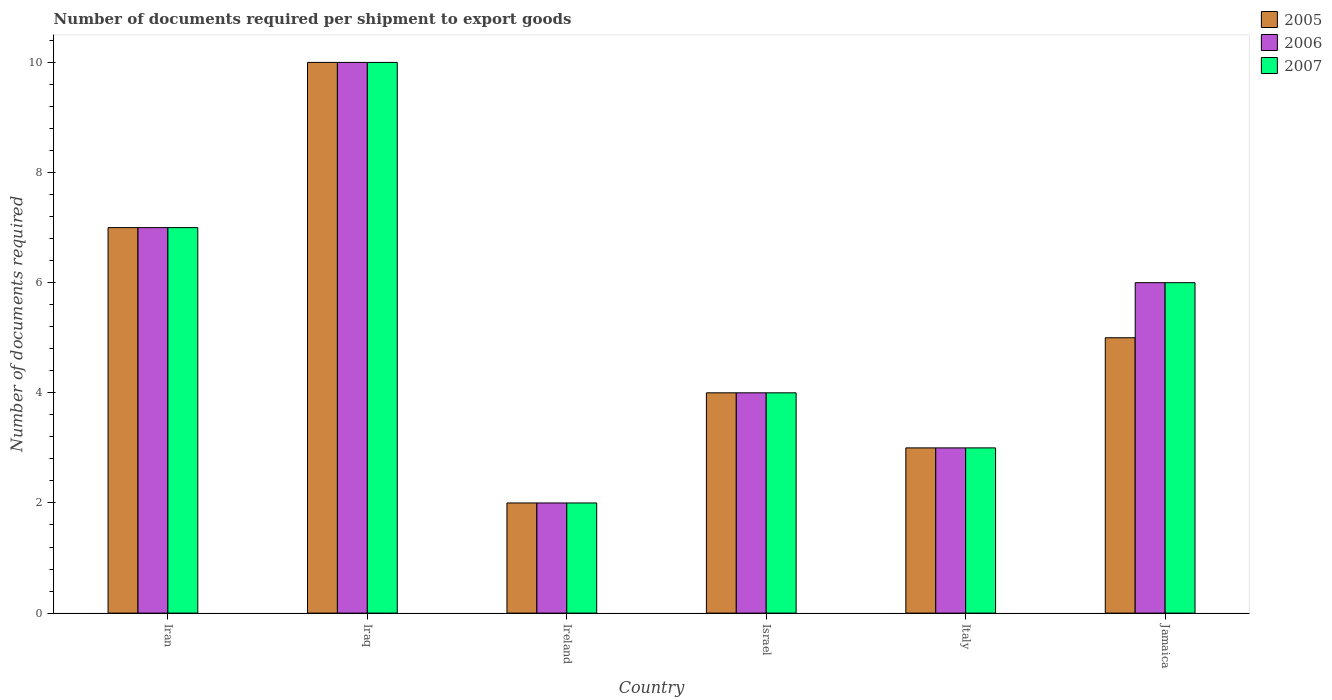What is the label of the 1st group of bars from the left?
Your answer should be compact. Iran. What is the number of documents required per shipment to export goods in 2006 in Jamaica?
Provide a succinct answer. 6. In which country was the number of documents required per shipment to export goods in 2007 maximum?
Your answer should be compact. Iraq. In which country was the number of documents required per shipment to export goods in 2007 minimum?
Keep it short and to the point. Ireland. What is the total number of documents required per shipment to export goods in 2006 in the graph?
Your answer should be very brief. 32. What is the difference between the number of documents required per shipment to export goods in 2005 in Ireland and the number of documents required per shipment to export goods in 2006 in Italy?
Your answer should be very brief. -1. What is the average number of documents required per shipment to export goods in 2005 per country?
Your answer should be very brief. 5.17. What is the ratio of the number of documents required per shipment to export goods in 2007 in Ireland to that in Jamaica?
Ensure brevity in your answer.  0.33. Is the number of documents required per shipment to export goods in 2005 in Israel less than that in Italy?
Provide a succinct answer. No. Is the difference between the number of documents required per shipment to export goods in 2007 in Italy and Jamaica greater than the difference between the number of documents required per shipment to export goods in 2006 in Italy and Jamaica?
Your answer should be very brief. No. In how many countries, is the number of documents required per shipment to export goods in 2005 greater than the average number of documents required per shipment to export goods in 2005 taken over all countries?
Ensure brevity in your answer.  2. What does the 1st bar from the right in Italy represents?
Your answer should be compact. 2007. Are all the bars in the graph horizontal?
Your response must be concise. No. What is the difference between two consecutive major ticks on the Y-axis?
Ensure brevity in your answer.  2. Does the graph contain any zero values?
Your answer should be compact. No. Where does the legend appear in the graph?
Offer a terse response. Top right. How many legend labels are there?
Offer a terse response. 3. How are the legend labels stacked?
Give a very brief answer. Vertical. What is the title of the graph?
Make the answer very short. Number of documents required per shipment to export goods. Does "1972" appear as one of the legend labels in the graph?
Offer a terse response. No. What is the label or title of the Y-axis?
Your answer should be very brief. Number of documents required. What is the Number of documents required in 2005 in Iran?
Offer a very short reply. 7. What is the Number of documents required of 2007 in Iran?
Give a very brief answer. 7. What is the Number of documents required of 2006 in Iraq?
Offer a terse response. 10. What is the Number of documents required in 2005 in Ireland?
Your answer should be very brief. 2. What is the Number of documents required of 2006 in Ireland?
Offer a very short reply. 2. What is the Number of documents required in 2005 in Italy?
Provide a succinct answer. 3. What is the Number of documents required in 2006 in Italy?
Offer a terse response. 3. Across all countries, what is the maximum Number of documents required in 2005?
Your answer should be very brief. 10. Across all countries, what is the maximum Number of documents required in 2007?
Offer a terse response. 10. Across all countries, what is the minimum Number of documents required in 2005?
Provide a succinct answer. 2. Across all countries, what is the minimum Number of documents required in 2006?
Offer a very short reply. 2. Across all countries, what is the minimum Number of documents required of 2007?
Keep it short and to the point. 2. What is the total Number of documents required in 2005 in the graph?
Your answer should be compact. 31. What is the total Number of documents required of 2007 in the graph?
Give a very brief answer. 32. What is the difference between the Number of documents required in 2006 in Iran and that in Iraq?
Provide a succinct answer. -3. What is the difference between the Number of documents required in 2007 in Iran and that in Iraq?
Give a very brief answer. -3. What is the difference between the Number of documents required in 2005 in Iran and that in Ireland?
Your response must be concise. 5. What is the difference between the Number of documents required in 2006 in Iran and that in Israel?
Provide a short and direct response. 3. What is the difference between the Number of documents required in 2005 in Iran and that in Italy?
Offer a very short reply. 4. What is the difference between the Number of documents required in 2006 in Iran and that in Italy?
Make the answer very short. 4. What is the difference between the Number of documents required in 2005 in Iran and that in Jamaica?
Provide a succinct answer. 2. What is the difference between the Number of documents required of 2007 in Iran and that in Jamaica?
Offer a terse response. 1. What is the difference between the Number of documents required in 2005 in Iraq and that in Israel?
Give a very brief answer. 6. What is the difference between the Number of documents required in 2006 in Iraq and that in Italy?
Your response must be concise. 7. What is the difference between the Number of documents required in 2006 in Ireland and that in Israel?
Offer a terse response. -2. What is the difference between the Number of documents required in 2007 in Ireland and that in Israel?
Your response must be concise. -2. What is the difference between the Number of documents required of 2005 in Israel and that in Italy?
Your response must be concise. 1. What is the difference between the Number of documents required of 2007 in Israel and that in Italy?
Provide a short and direct response. 1. What is the difference between the Number of documents required in 2007 in Israel and that in Jamaica?
Make the answer very short. -2. What is the difference between the Number of documents required of 2005 in Italy and that in Jamaica?
Ensure brevity in your answer.  -2. What is the difference between the Number of documents required of 2006 in Italy and that in Jamaica?
Your response must be concise. -3. What is the difference between the Number of documents required of 2007 in Italy and that in Jamaica?
Make the answer very short. -3. What is the difference between the Number of documents required of 2006 in Iran and the Number of documents required of 2007 in Iraq?
Provide a succinct answer. -3. What is the difference between the Number of documents required of 2005 in Iran and the Number of documents required of 2006 in Ireland?
Give a very brief answer. 5. What is the difference between the Number of documents required in 2006 in Iran and the Number of documents required in 2007 in Ireland?
Make the answer very short. 5. What is the difference between the Number of documents required in 2005 in Iran and the Number of documents required in 2007 in Israel?
Ensure brevity in your answer.  3. What is the difference between the Number of documents required in 2006 in Iran and the Number of documents required in 2007 in Israel?
Make the answer very short. 3. What is the difference between the Number of documents required of 2005 in Iran and the Number of documents required of 2007 in Italy?
Offer a terse response. 4. What is the difference between the Number of documents required of 2005 in Iraq and the Number of documents required of 2007 in Ireland?
Provide a succinct answer. 8. What is the difference between the Number of documents required in 2005 in Iraq and the Number of documents required in 2007 in Italy?
Your answer should be compact. 7. What is the difference between the Number of documents required in 2006 in Iraq and the Number of documents required in 2007 in Italy?
Your answer should be compact. 7. What is the difference between the Number of documents required in 2005 in Iraq and the Number of documents required in 2006 in Jamaica?
Offer a very short reply. 4. What is the difference between the Number of documents required in 2005 in Iraq and the Number of documents required in 2007 in Jamaica?
Give a very brief answer. 4. What is the difference between the Number of documents required of 2006 in Ireland and the Number of documents required of 2007 in Israel?
Offer a very short reply. -2. What is the difference between the Number of documents required of 2005 in Ireland and the Number of documents required of 2007 in Italy?
Ensure brevity in your answer.  -1. What is the difference between the Number of documents required of 2006 in Ireland and the Number of documents required of 2007 in Italy?
Your response must be concise. -1. What is the difference between the Number of documents required in 2005 in Ireland and the Number of documents required in 2006 in Jamaica?
Keep it short and to the point. -4. What is the difference between the Number of documents required in 2005 in Ireland and the Number of documents required in 2007 in Jamaica?
Offer a very short reply. -4. What is the difference between the Number of documents required of 2006 in Ireland and the Number of documents required of 2007 in Jamaica?
Provide a succinct answer. -4. What is the difference between the Number of documents required in 2005 in Israel and the Number of documents required in 2006 in Italy?
Make the answer very short. 1. What is the difference between the Number of documents required of 2005 in Israel and the Number of documents required of 2007 in Jamaica?
Provide a succinct answer. -2. What is the difference between the Number of documents required of 2006 in Israel and the Number of documents required of 2007 in Jamaica?
Offer a very short reply. -2. What is the difference between the Number of documents required in 2005 in Italy and the Number of documents required in 2007 in Jamaica?
Provide a short and direct response. -3. What is the average Number of documents required of 2005 per country?
Your response must be concise. 5.17. What is the average Number of documents required of 2006 per country?
Offer a terse response. 5.33. What is the average Number of documents required in 2007 per country?
Keep it short and to the point. 5.33. What is the difference between the Number of documents required of 2006 and Number of documents required of 2007 in Iran?
Make the answer very short. 0. What is the difference between the Number of documents required in 2005 and Number of documents required in 2007 in Iraq?
Ensure brevity in your answer.  0. What is the difference between the Number of documents required of 2005 and Number of documents required of 2006 in Ireland?
Your answer should be compact. 0. What is the difference between the Number of documents required in 2005 and Number of documents required in 2007 in Ireland?
Your answer should be compact. 0. What is the difference between the Number of documents required in 2006 and Number of documents required in 2007 in Ireland?
Make the answer very short. 0. What is the difference between the Number of documents required in 2005 and Number of documents required in 2006 in Israel?
Your response must be concise. 0. What is the difference between the Number of documents required of 2005 and Number of documents required of 2007 in Israel?
Provide a succinct answer. 0. What is the difference between the Number of documents required in 2006 and Number of documents required in 2007 in Israel?
Your response must be concise. 0. What is the difference between the Number of documents required of 2005 and Number of documents required of 2007 in Italy?
Provide a succinct answer. 0. What is the difference between the Number of documents required in 2005 and Number of documents required in 2006 in Jamaica?
Offer a very short reply. -1. What is the ratio of the Number of documents required in 2005 in Iran to that in Ireland?
Your response must be concise. 3.5. What is the ratio of the Number of documents required of 2006 in Iran to that in Ireland?
Ensure brevity in your answer.  3.5. What is the ratio of the Number of documents required in 2007 in Iran to that in Ireland?
Offer a very short reply. 3.5. What is the ratio of the Number of documents required of 2005 in Iran to that in Italy?
Provide a short and direct response. 2.33. What is the ratio of the Number of documents required in 2006 in Iran to that in Italy?
Your answer should be compact. 2.33. What is the ratio of the Number of documents required of 2007 in Iran to that in Italy?
Offer a very short reply. 2.33. What is the ratio of the Number of documents required of 2005 in Iran to that in Jamaica?
Ensure brevity in your answer.  1.4. What is the ratio of the Number of documents required of 2007 in Iran to that in Jamaica?
Offer a terse response. 1.17. What is the ratio of the Number of documents required of 2005 in Iraq to that in Israel?
Your answer should be very brief. 2.5. What is the ratio of the Number of documents required of 2006 in Iraq to that in Italy?
Your answer should be compact. 3.33. What is the ratio of the Number of documents required of 2005 in Iraq to that in Jamaica?
Give a very brief answer. 2. What is the ratio of the Number of documents required in 2006 in Iraq to that in Jamaica?
Your answer should be very brief. 1.67. What is the ratio of the Number of documents required of 2005 in Ireland to that in Israel?
Keep it short and to the point. 0.5. What is the ratio of the Number of documents required of 2006 in Ireland to that in Israel?
Offer a terse response. 0.5. What is the ratio of the Number of documents required in 2007 in Ireland to that in Israel?
Give a very brief answer. 0.5. What is the ratio of the Number of documents required of 2005 in Ireland to that in Italy?
Make the answer very short. 0.67. What is the ratio of the Number of documents required of 2006 in Ireland to that in Italy?
Offer a very short reply. 0.67. What is the ratio of the Number of documents required in 2006 in Ireland to that in Jamaica?
Provide a short and direct response. 0.33. What is the ratio of the Number of documents required of 2005 in Israel to that in Italy?
Ensure brevity in your answer.  1.33. What is the ratio of the Number of documents required in 2006 in Israel to that in Italy?
Keep it short and to the point. 1.33. What is the ratio of the Number of documents required in 2006 in Italy to that in Jamaica?
Make the answer very short. 0.5. What is the difference between the highest and the second highest Number of documents required of 2005?
Offer a terse response. 3. What is the difference between the highest and the second highest Number of documents required in 2006?
Offer a very short reply. 3. What is the difference between the highest and the second highest Number of documents required of 2007?
Keep it short and to the point. 3. What is the difference between the highest and the lowest Number of documents required in 2005?
Keep it short and to the point. 8. What is the difference between the highest and the lowest Number of documents required in 2007?
Ensure brevity in your answer.  8. 